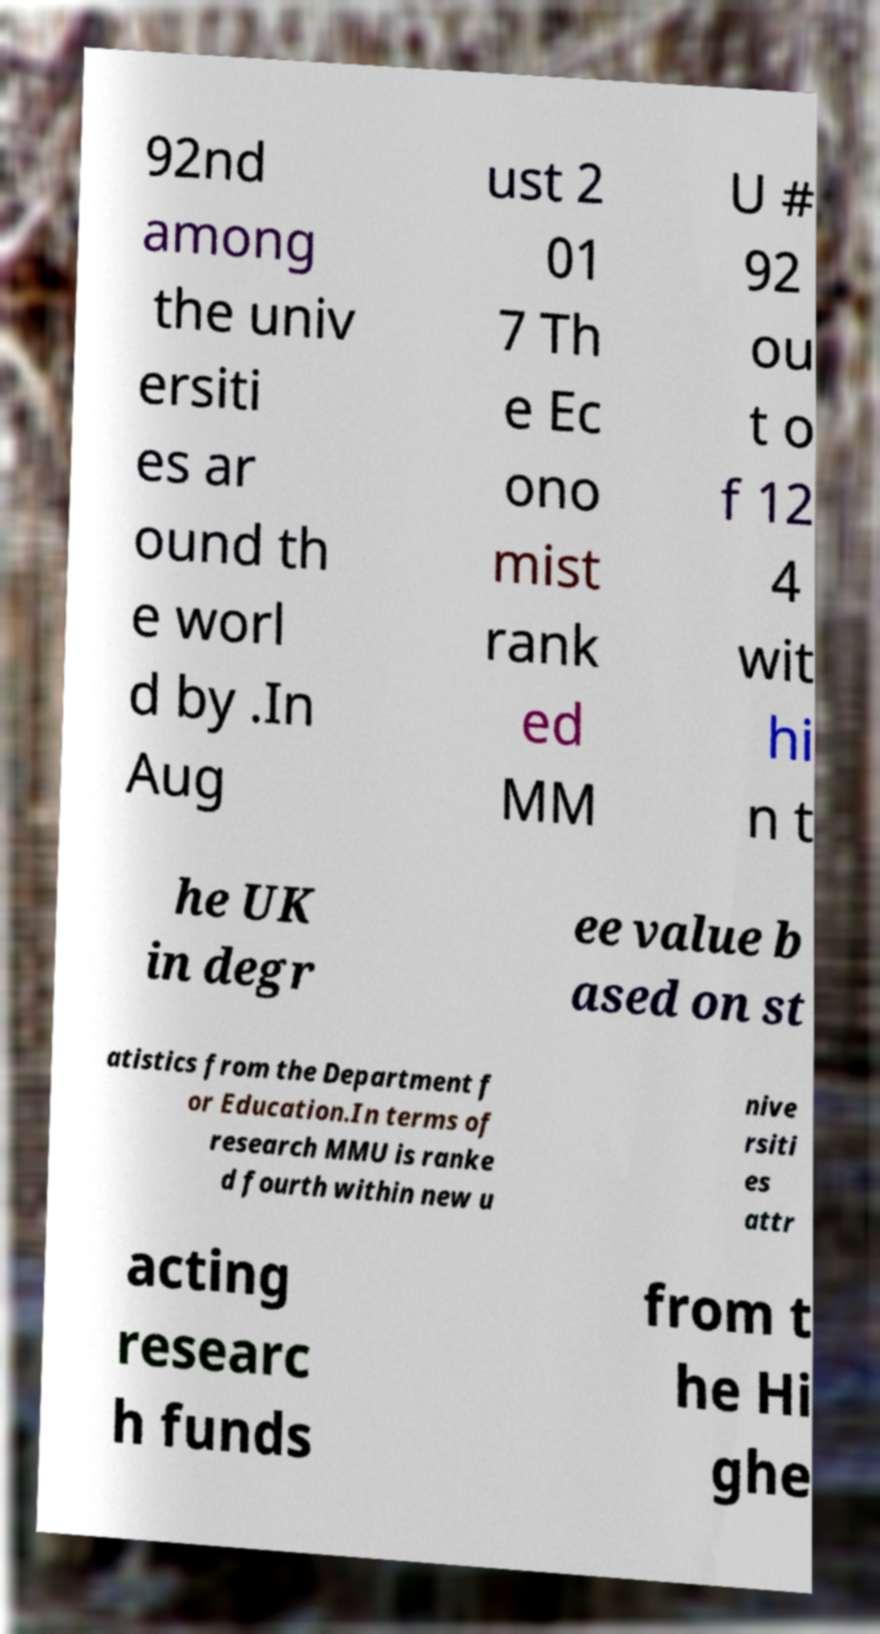Can you accurately transcribe the text from the provided image for me? 92nd among the univ ersiti es ar ound th e worl d by .In Aug ust 2 01 7 Th e Ec ono mist rank ed MM U # 92 ou t o f 12 4 wit hi n t he UK in degr ee value b ased on st atistics from the Department f or Education.In terms of research MMU is ranke d fourth within new u nive rsiti es attr acting researc h funds from t he Hi ghe 